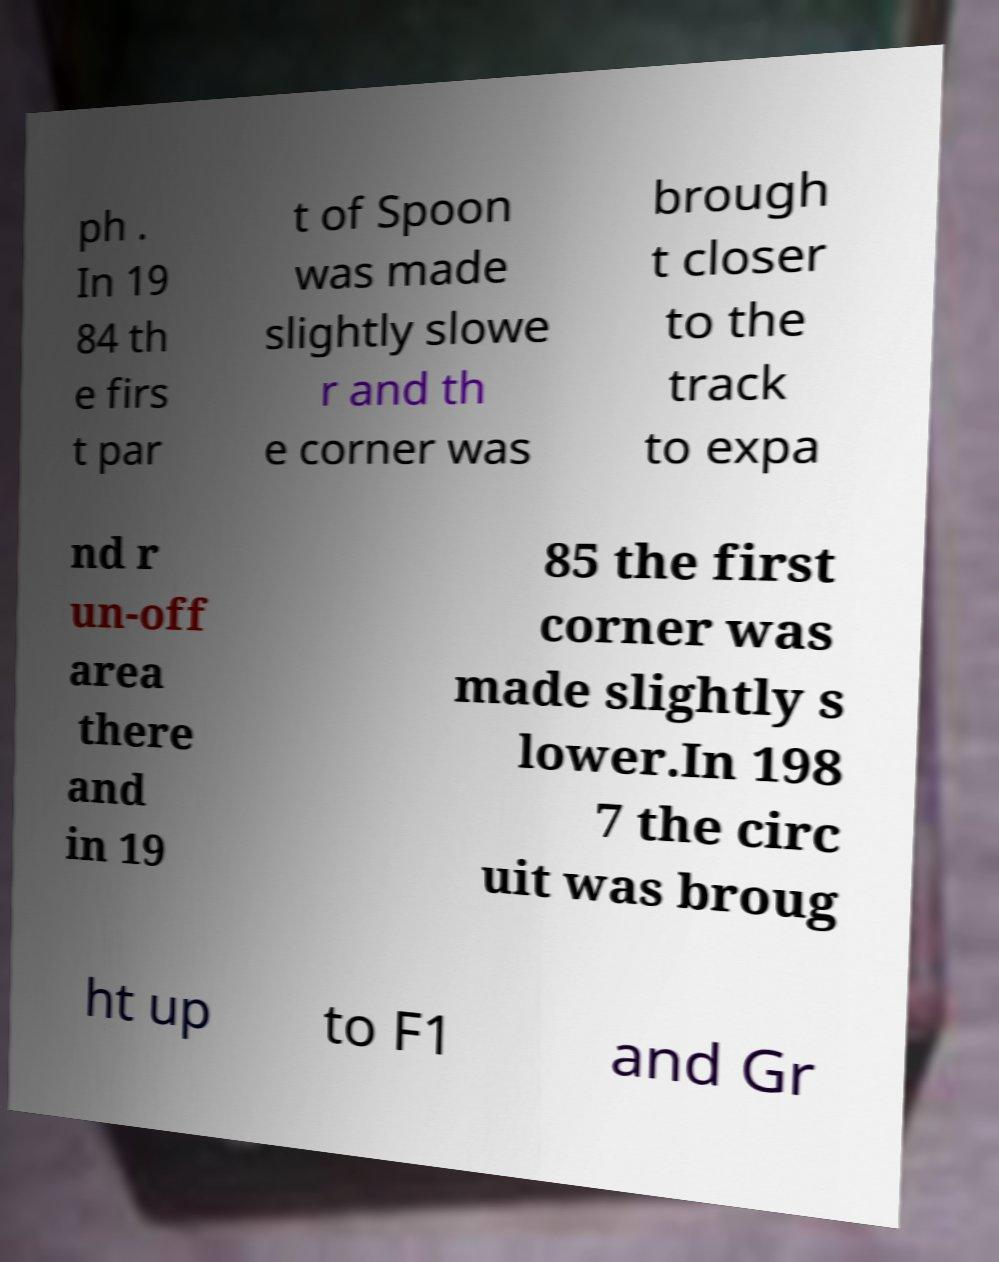Please identify and transcribe the text found in this image. ph . In 19 84 th e firs t par t of Spoon was made slightly slowe r and th e corner was brough t closer to the track to expa nd r un-off area there and in 19 85 the first corner was made slightly s lower.In 198 7 the circ uit was broug ht up to F1 and Gr 